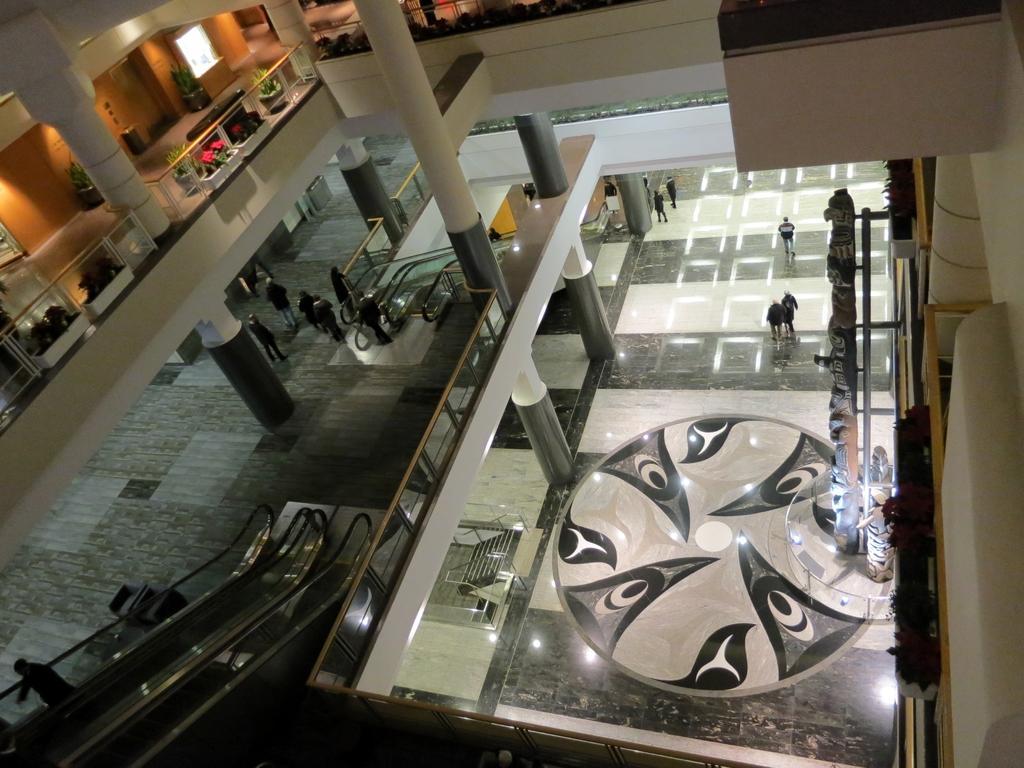Can you describe this image briefly? This image is clicked from top of building and there is a ground in the middle and there is a design on the floor beside there is a pole and on which sculptures attached , some persons visible on stair case and beams visible on the ground, and there is a escalator and persons visible at above the ground and top which I can see another floor and on the floor I can see flower pots, plants ,window 